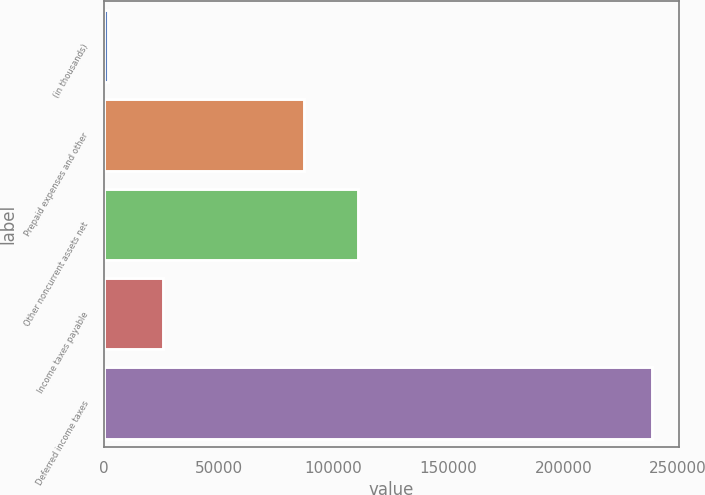Convert chart. <chart><loc_0><loc_0><loc_500><loc_500><bar_chart><fcel>(in thousands)<fcel>Prepaid expenses and other<fcel>Other noncurrent assets net<fcel>Income taxes payable<fcel>Deferred income taxes<nl><fcel>2013<fcel>86929<fcel>110567<fcel>25651.1<fcel>238394<nl></chart> 